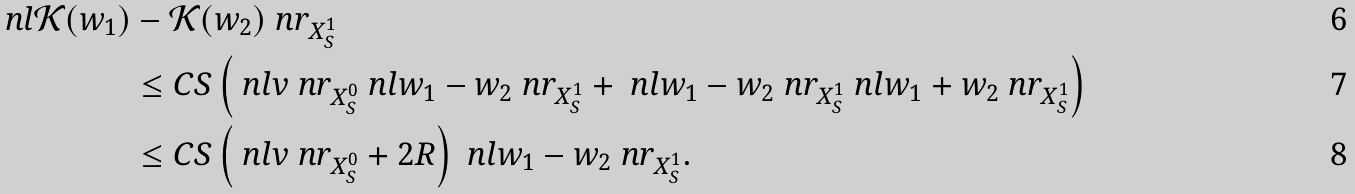Convert formula to latex. <formula><loc_0><loc_0><loc_500><loc_500>\ n l \mathcal { K } ( w _ { 1 } ) & - \mathcal { K } ( w _ { 2 } ) \ n r _ { X _ { S } ^ { 1 } } \\ & \leq C S \left ( \ n l v \ n r _ { X _ { S } ^ { 0 } } \ n l w _ { 1 } - w _ { 2 } \ n r _ { X _ { S } ^ { 1 } } + \ n l w _ { 1 } - w _ { 2 } \ n r _ { X _ { S } ^ { 1 } } \ n l w _ { 1 } + w _ { 2 } \ n r _ { X _ { S } ^ { 1 } } \right ) \\ & \leq C S \left ( \ n l v \ n r _ { X _ { S } ^ { 0 } } + 2 R \right ) \ n l w _ { 1 } - w _ { 2 } \ n r _ { X _ { S } ^ { 1 } } .</formula> 